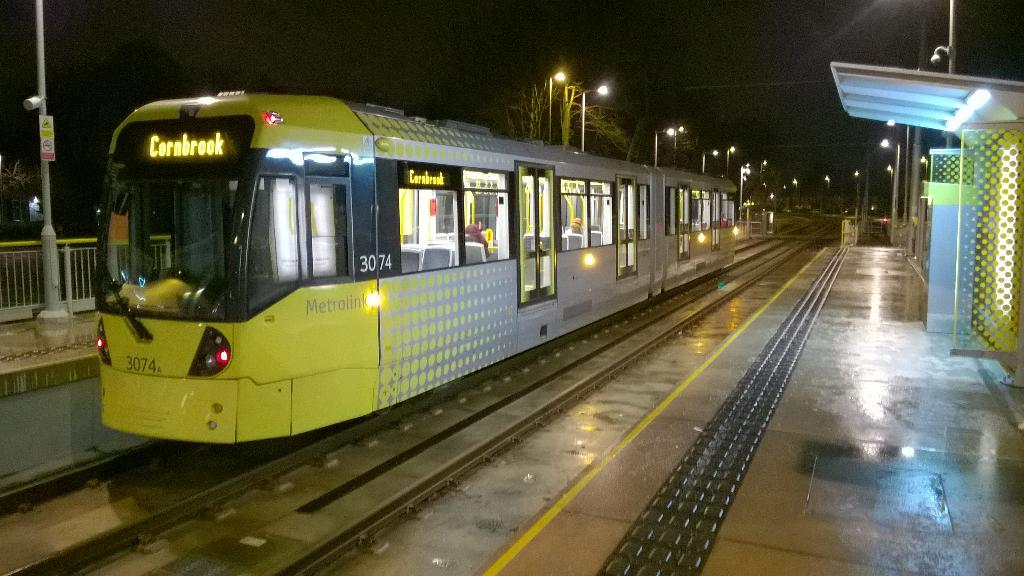Provide a one-sentence caption for the provided image. Train station with a yellow and silver train with Cornbrook on the front. 